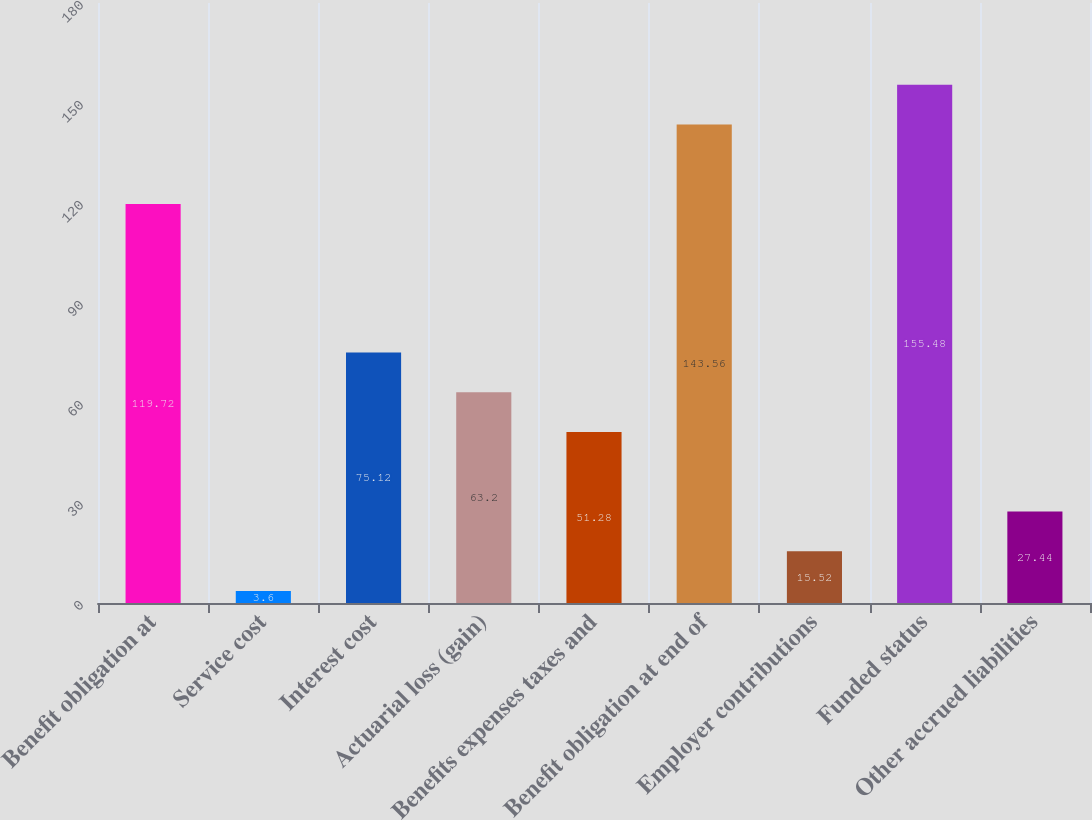<chart> <loc_0><loc_0><loc_500><loc_500><bar_chart><fcel>Benefit obligation at<fcel>Service cost<fcel>Interest cost<fcel>Actuarial loss (gain)<fcel>Benefits expenses taxes and<fcel>Benefit obligation at end of<fcel>Employer contributions<fcel>Funded status<fcel>Other accrued liabilities<nl><fcel>119.72<fcel>3.6<fcel>75.12<fcel>63.2<fcel>51.28<fcel>143.56<fcel>15.52<fcel>155.48<fcel>27.44<nl></chart> 